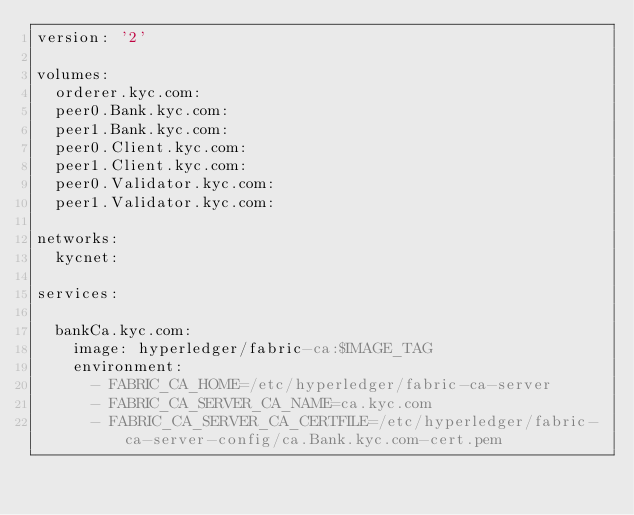<code> <loc_0><loc_0><loc_500><loc_500><_YAML_>version: '2'

volumes:
  orderer.kyc.com:
  peer0.Bank.kyc.com:
  peer1.Bank.kyc.com:
  peer0.Client.kyc.com:
  peer1.Client.kyc.com:
  peer0.Validator.kyc.com:
  peer1.Validator.kyc.com:

networks:
  kycnet:

services:

  bankCa.kyc.com:
    image: hyperledger/fabric-ca:$IMAGE_TAG
    environment:
      - FABRIC_CA_HOME=/etc/hyperledger/fabric-ca-server
      - FABRIC_CA_SERVER_CA_NAME=ca.kyc.com
      - FABRIC_CA_SERVER_CA_CERTFILE=/etc/hyperledger/fabric-ca-server-config/ca.Bank.kyc.com-cert.pem</code> 